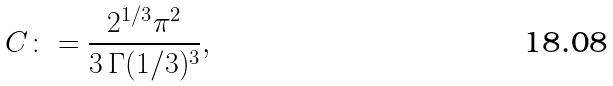<formula> <loc_0><loc_0><loc_500><loc_500>C \colon = \frac { 2 ^ { 1 / 3 } \pi ^ { 2 } } { 3 \, \Gamma ( 1 / 3 ) ^ { 3 } } ,</formula> 